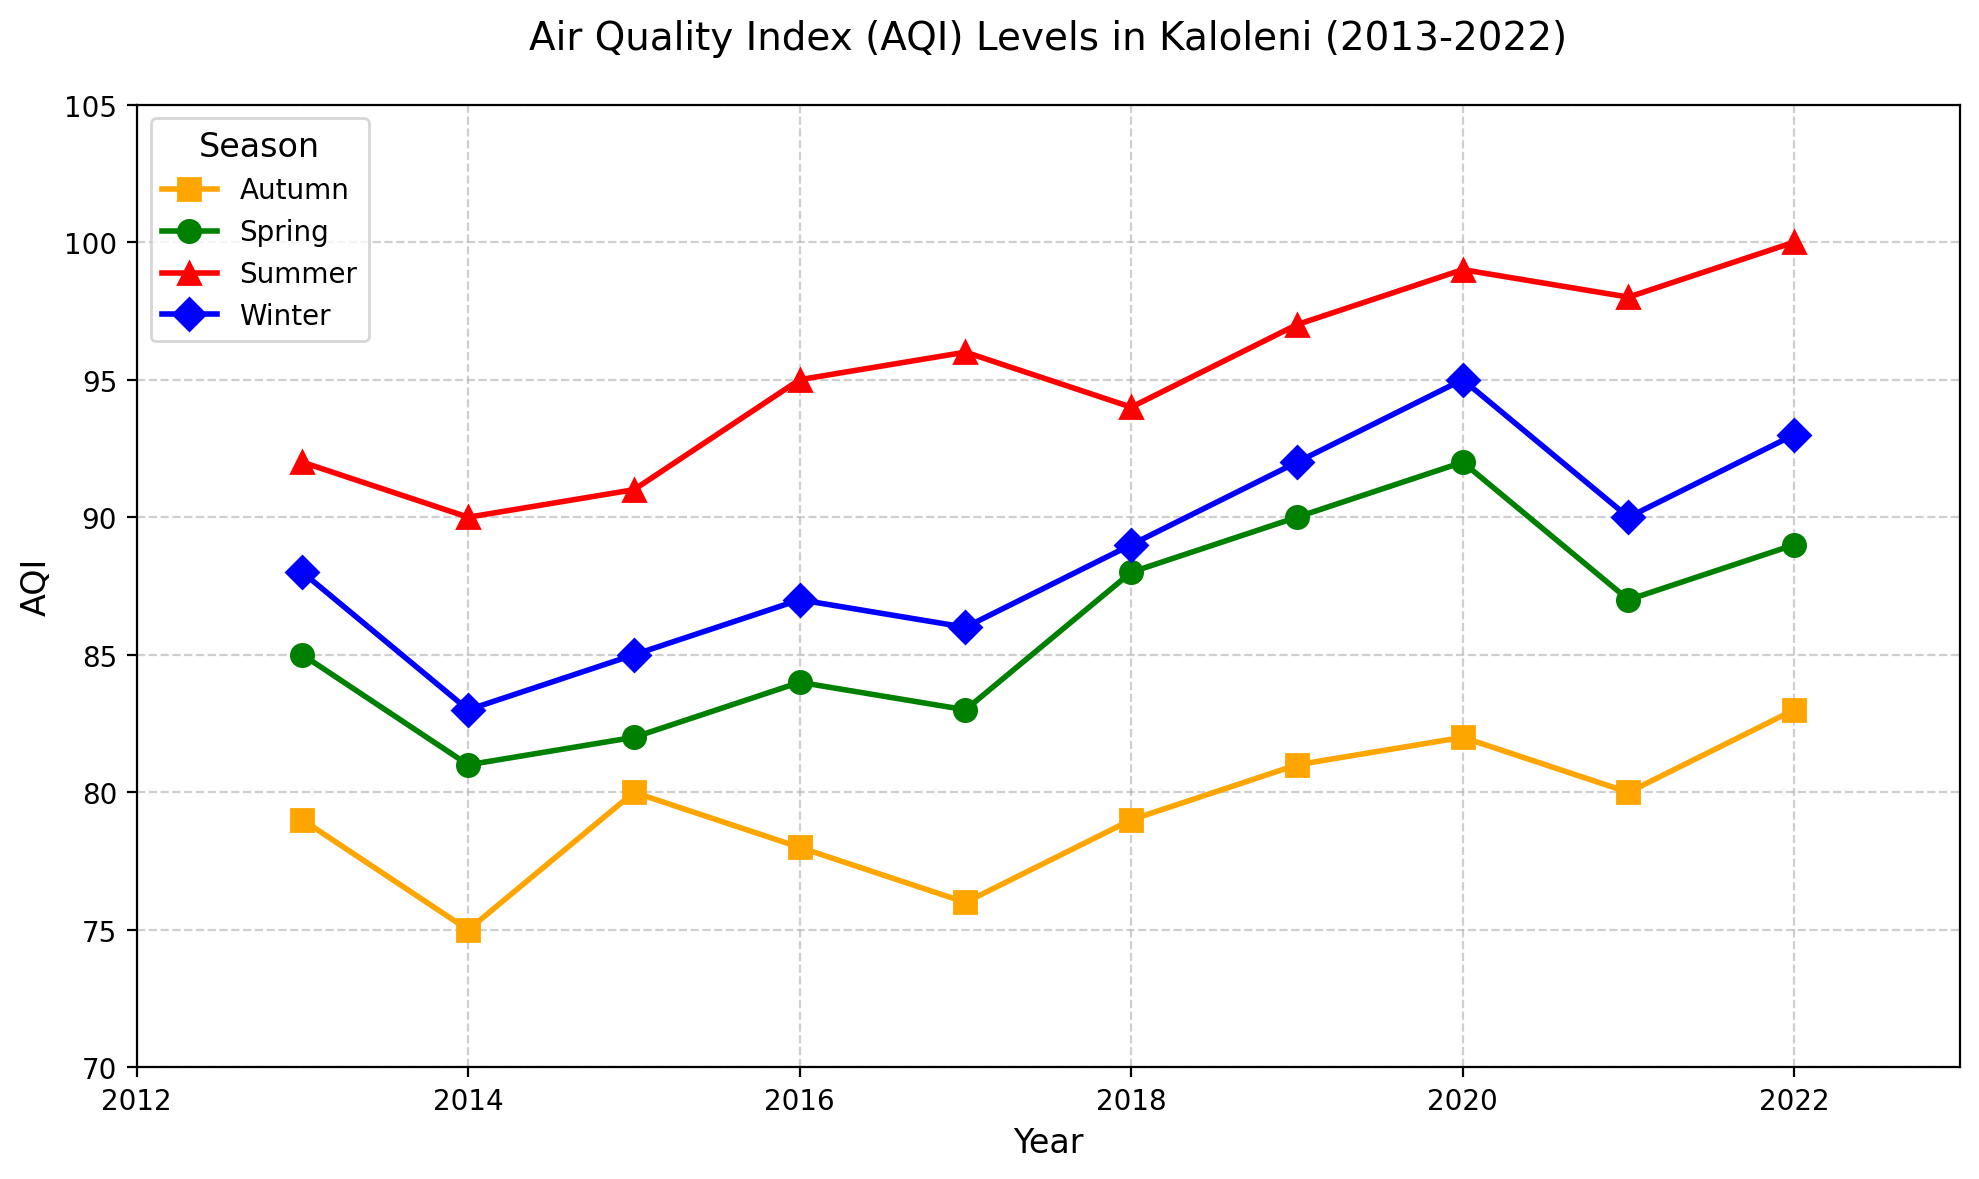What's the average AQI during summer for the entire period? To find the average AQI during summer from 2013 to 2022, sum up the summer AQI values and divide by the number of years. The values are (92 + 90 + 91 + 95 + 96 + 94 + 97 + 99 + 98 + 100) = 952; there are 10 years, so 952 / 10 = 95.2
Answer: 95.2 Which season had the highest AQI in 2022? Check the AQI values for each season in 2022. Spring = 89, Summer = 100, Autumn = 83, Winter = 93. Summer has the highest value of 100
Answer: Summer In which year did winter have the lowest AQI? Compare the winter AQI values across all years: 2013 = 88, 2014 = 83, 2015 = 85, 2016 = 87, 2017 = 86, 2018 = 89, 2019 = 92, 2020 = 95, 2021 = 90, 2022 = 93. The lowest value is 83 in 2014
Answer: 2014 What's the difference between the highest and lowest AQI recorded in autumn from 2013-2022? Identify the highest and lowest values for autumn: highest is 83 in 2022, and lowest is 75 in 2014. The difference is 83 - 75 = 8
Answer: 8 How did the AQI trend for winter change from 2013 to 2022? Observe the winter AQI values year by year: 2013 = 88, 2014 = 83, 2015 = 85, 2016 = 87, 2017 = 86, 2018 = 89, 2019 = 92, 2020 = 95, 2021 = 90, 2022 = 93. Generally, the trend increases with minor fluctuations
Answer: Increased with fluctuations In which year did the AQI in spring surpass 90 for the first time? Look for the first occurrence where spring AQI surpasses 90. It is in 2020 with an AQI of 92
Answer: 2020 What's the average AQI across all seasons in 2019? Sum the AQI values for all seasons in 2019 and divide by 4. Values are (90 + 97 + 81 + 92) = 360; average is 360 / 4 = 90
Answer: 90 Compare the average AQI of summer and autumn over the decade. Which is higher? Calculate the average AQI for summer and autumn separately over the decade. Summer: (92 + 90 + 91 + 95 + 96 + 94 + 97 + 99 + 98 + 100) = 952, average is 952 / 10 = 95.2. Autumn: (79 + 75 + 80 + 78 + 76 + 79 + 81 + 82 + 80 + 83) = 793, average is 793 / 10 = 79.3. Summer AQI average (95.2) is higher than autumn AQI average (79.3)
Answer: Summer What is the range of the AQI values for the year 2020? The AQI values for 2020 are spring = 92, summer = 99, autumn = 82, winter = 95. The range is the difference between the highest and lowest: 99 - 82 = 17
Answer: 17 